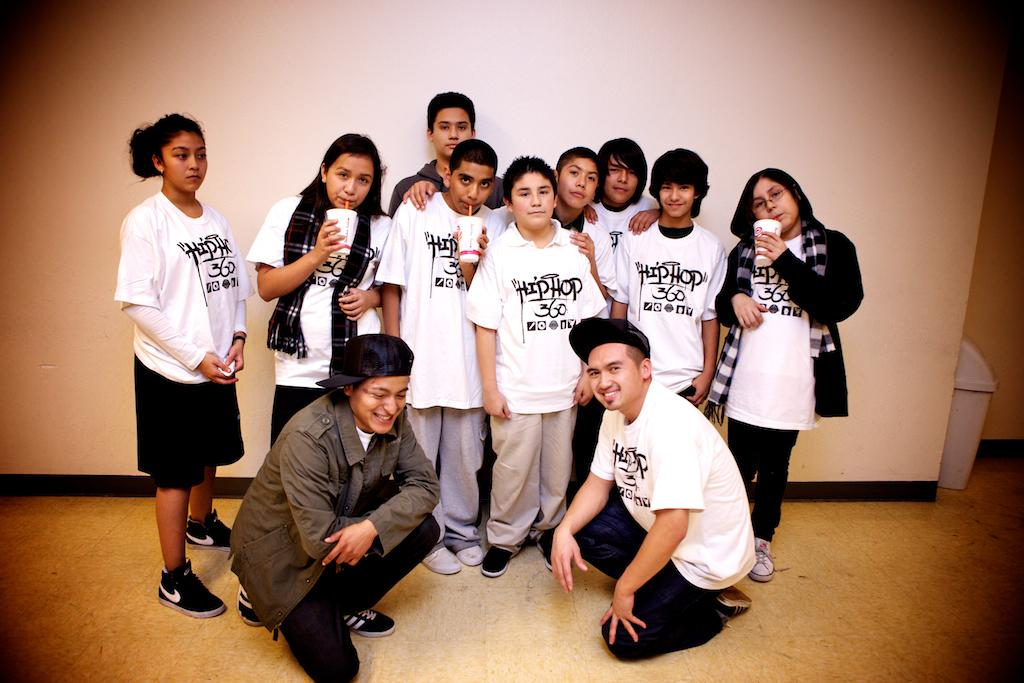What is the main subject of the image? The main subject of the image is a group of children. What are some of the children holding in the image? Some of the children are holding glasses. What can be seen in the background of the image? There is a wall in the background of the image. What is the color and location of the container visible in the image? There is a white color container visible on the right side of the image. What type of cow can be seen in the image? There is no cow present in the image. Is the image set during the night? The image does not provide any information about the time of day, so it cannot be determined if it is set during the night. 